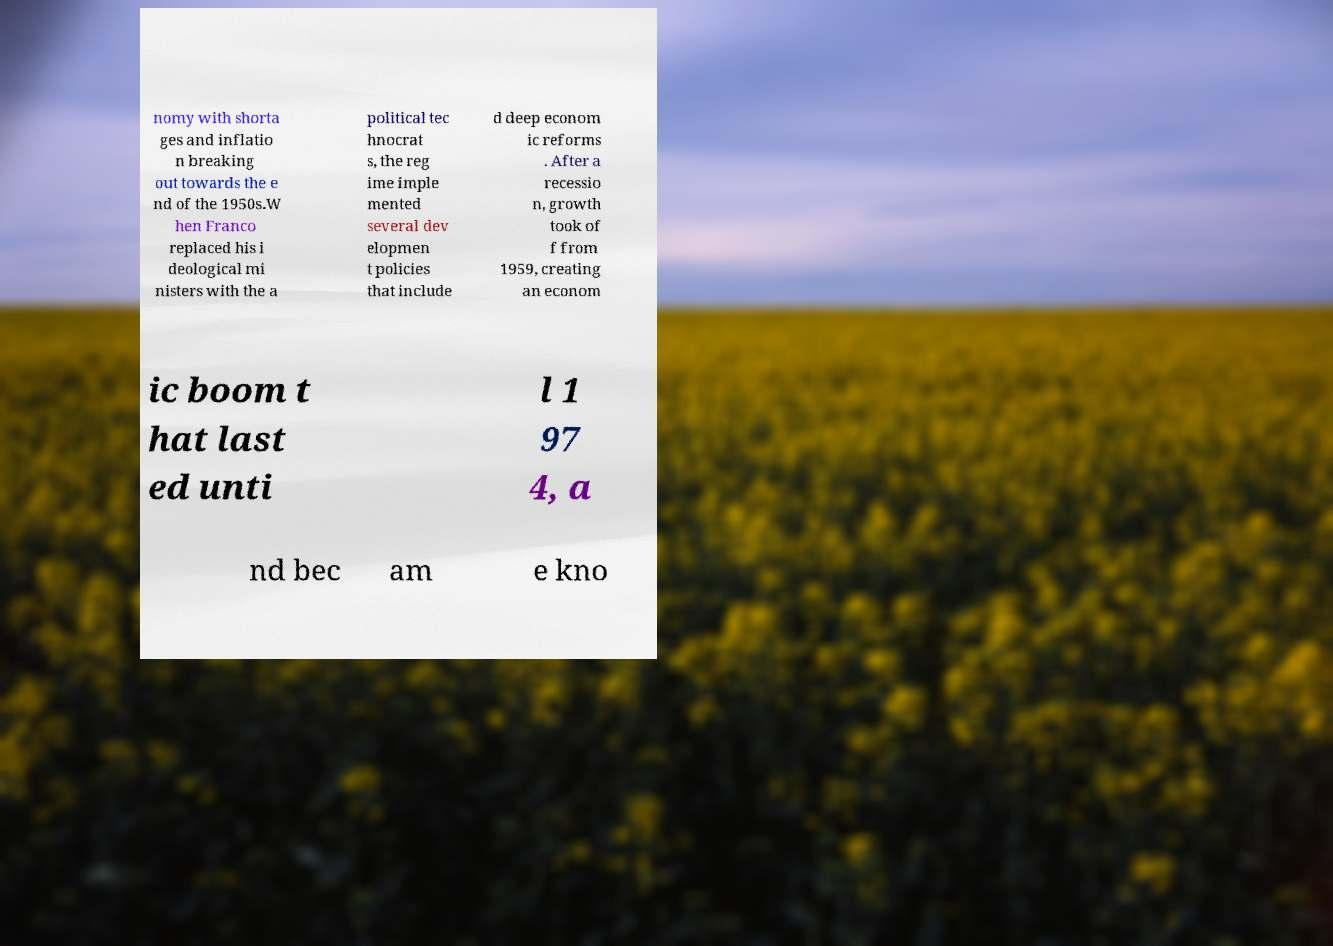I need the written content from this picture converted into text. Can you do that? nomy with shorta ges and inflatio n breaking out towards the e nd of the 1950s.W hen Franco replaced his i deological mi nisters with the a political tec hnocrat s, the reg ime imple mented several dev elopmen t policies that include d deep econom ic reforms . After a recessio n, growth took of f from 1959, creating an econom ic boom t hat last ed unti l 1 97 4, a nd bec am e kno 